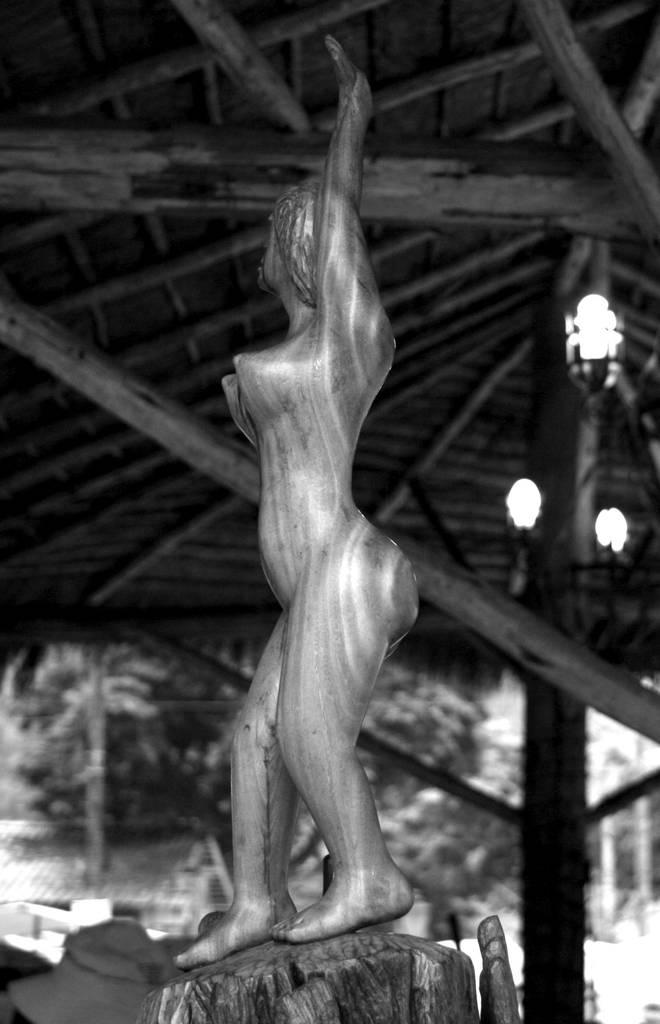What is the color scheme of the image? The image is black and white. What can be seen in the image besides the black and white color scheme? There is a statue of a person in the image. What is the statue standing on? The statue is on a wooden surface. What is visible at the top of the image? The roof is visible at the top of the image. What can be seen in the background of the image? There are trees and a shed in the background of the image. What type of jam is being served on the wooden surface in the image? There is no jam present in the image; it features a statue of a person on a wooden surface. How many dimes are visible on the roof in the image? There are no dimes visible on the roof in the image; it only shows the roof and not any objects on it. 